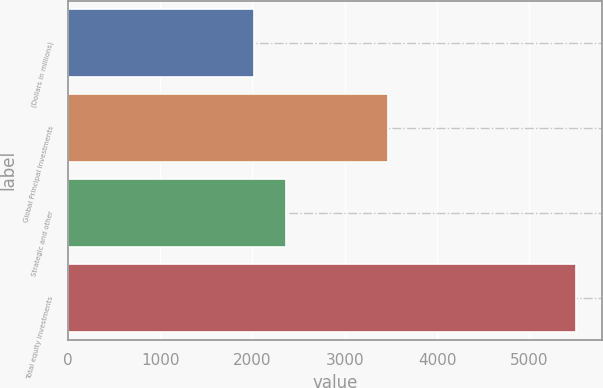Convert chart. <chart><loc_0><loc_0><loc_500><loc_500><bar_chart><fcel>(Dollars in millions)<fcel>Global Principal Investments<fcel>Strategic and other<fcel>Total equity investments<nl><fcel>2012<fcel>3470<fcel>2361.6<fcel>5508<nl></chart> 